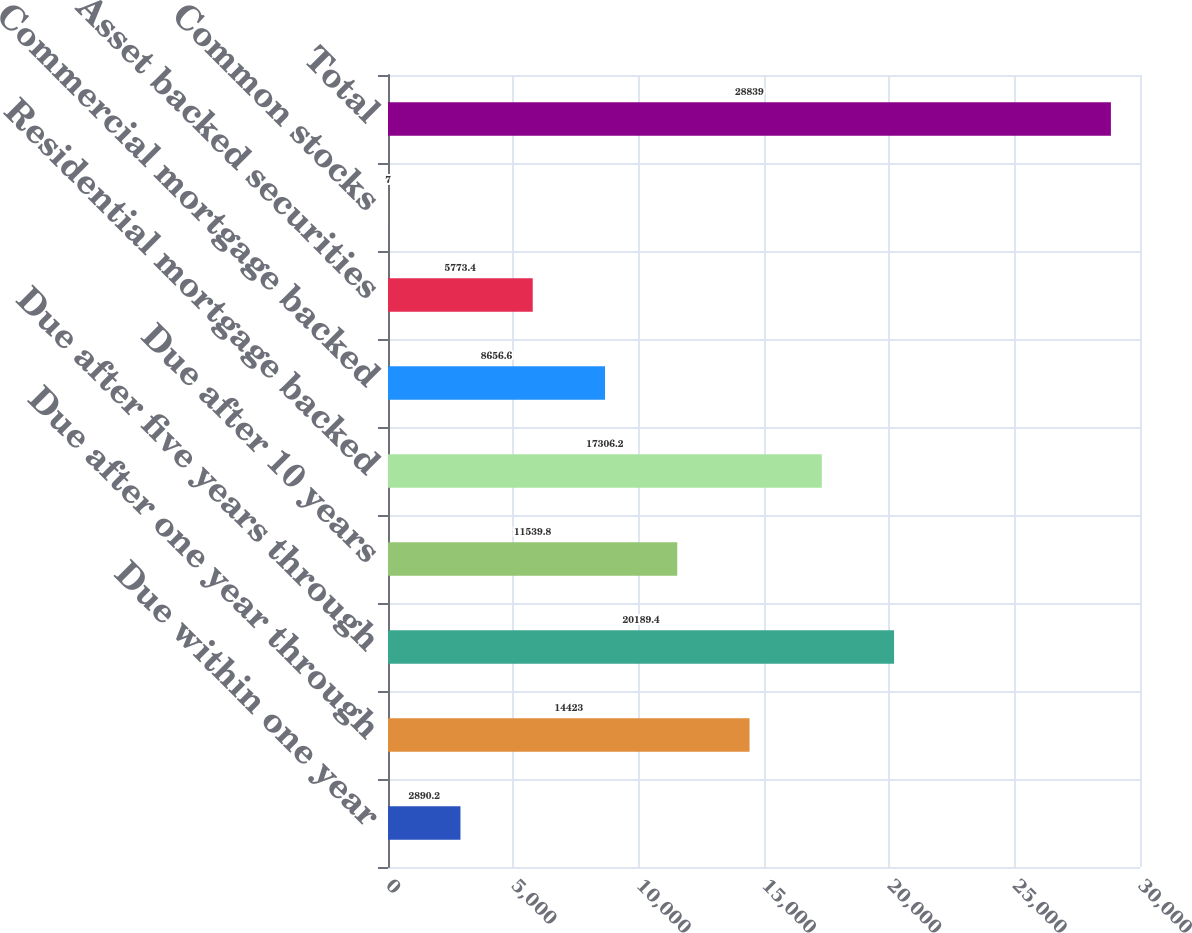Convert chart. <chart><loc_0><loc_0><loc_500><loc_500><bar_chart><fcel>Due within one year<fcel>Due after one year through<fcel>Due after five years through<fcel>Due after 10 years<fcel>Residential mortgage backed<fcel>Commercial mortgage backed<fcel>Asset backed securities<fcel>Common stocks<fcel>Total<nl><fcel>2890.2<fcel>14423<fcel>20189.4<fcel>11539.8<fcel>17306.2<fcel>8656.6<fcel>5773.4<fcel>7<fcel>28839<nl></chart> 